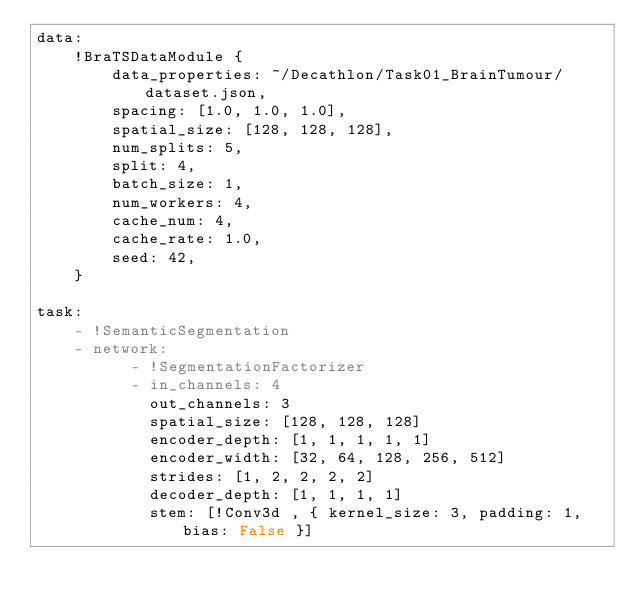Convert code to text. <code><loc_0><loc_0><loc_500><loc_500><_YAML_>data:
    !BraTSDataModule {
        data_properties: ~/Decathlon/Task01_BrainTumour/dataset.json,
        spacing: [1.0, 1.0, 1.0],
        spatial_size: [128, 128, 128],
        num_splits: 5,
        split: 4,
        batch_size: 1,
        num_workers: 4,
        cache_num: 4,
        cache_rate: 1.0,
        seed: 42,
    }

task:
    - !SemanticSegmentation
    - network:
          - !SegmentationFactorizer
          - in_channels: 4
            out_channels: 3
            spatial_size: [128, 128, 128]
            encoder_depth: [1, 1, 1, 1, 1]
            encoder_width: [32, 64, 128, 256, 512]
            strides: [1, 2, 2, 2, 2]
            decoder_depth: [1, 1, 1, 1]
            stem: [!Conv3d , { kernel_size: 3, padding: 1, bias: False }]</code> 